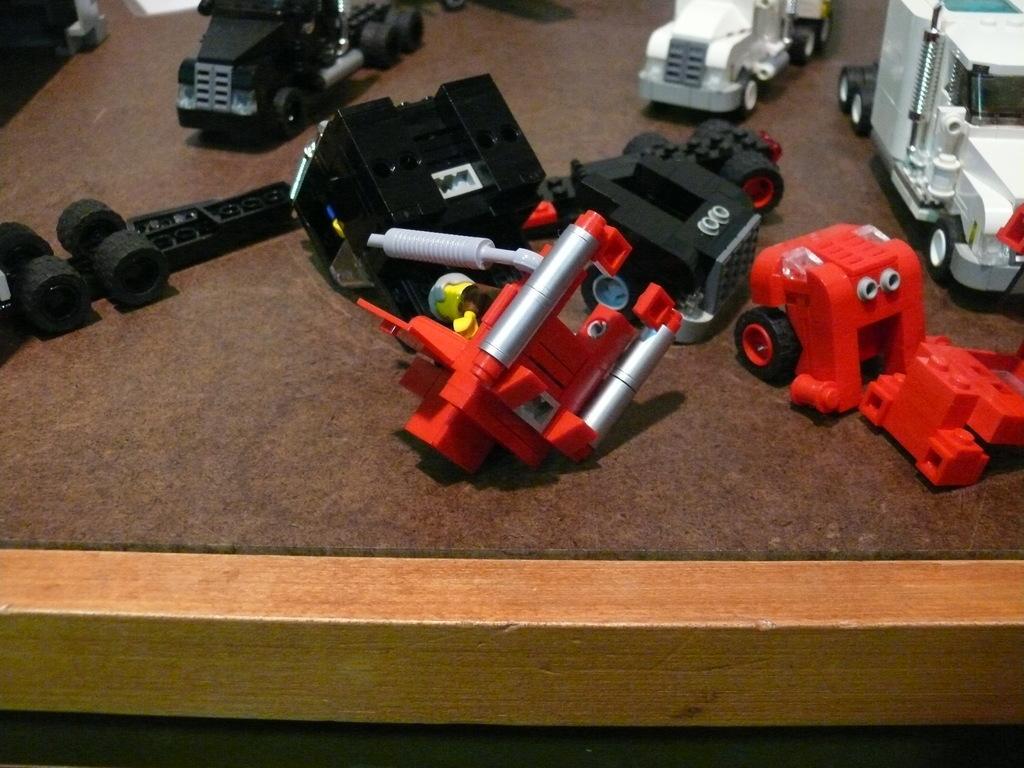In one or two sentences, can you explain what this image depicts? Here in this picture we can see toys, such as trucks and other things present on a table. 